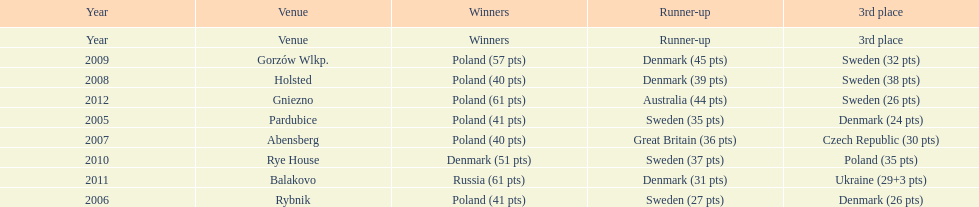When was the first year that poland did not place in the top three positions of the team speedway junior world championship? 2011. 